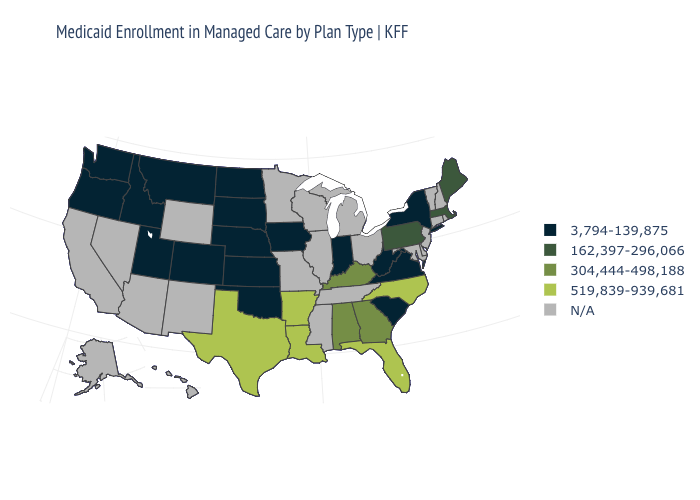What is the value of Maryland?
Short answer required. N/A. Is the legend a continuous bar?
Keep it brief. No. What is the lowest value in the Northeast?
Give a very brief answer. 3,794-139,875. What is the value of Illinois?
Keep it brief. N/A. Name the states that have a value in the range N/A?
Answer briefly. Alaska, Arizona, California, Connecticut, Delaware, Hawaii, Illinois, Maryland, Michigan, Minnesota, Mississippi, Missouri, Nevada, New Hampshire, New Jersey, New Mexico, Ohio, Rhode Island, Tennessee, Vermont, Wisconsin, Wyoming. Name the states that have a value in the range 3,794-139,875?
Concise answer only. Colorado, Idaho, Indiana, Iowa, Kansas, Montana, Nebraska, New York, North Dakota, Oklahoma, Oregon, South Carolina, South Dakota, Utah, Virginia, Washington, West Virginia. What is the value of Iowa?
Be succinct. 3,794-139,875. Is the legend a continuous bar?
Give a very brief answer. No. What is the lowest value in the USA?
Keep it brief. 3,794-139,875. Does the map have missing data?
Quick response, please. Yes. Name the states that have a value in the range 3,794-139,875?
Short answer required. Colorado, Idaho, Indiana, Iowa, Kansas, Montana, Nebraska, New York, North Dakota, Oklahoma, Oregon, South Carolina, South Dakota, Utah, Virginia, Washington, West Virginia. Name the states that have a value in the range 519,839-939,681?
Keep it brief. Arkansas, Florida, Louisiana, North Carolina, Texas. Does Arkansas have the highest value in the USA?
Write a very short answer. Yes. 